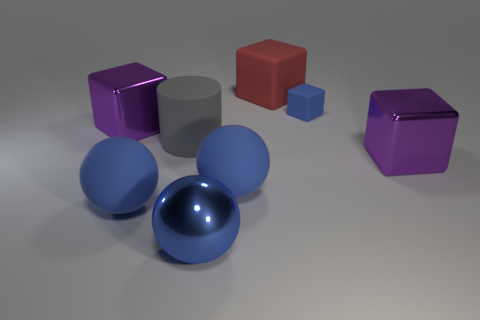What is the shape of the large blue object that is to the right of the metal object in front of the large purple cube that is on the right side of the red block?
Make the answer very short. Sphere. What number of things are either big blue balls on the right side of the big blue metal ball or metal blocks that are right of the blue cube?
Offer a very short reply. 2. Does the blue matte cube have the same size as the purple object that is on the left side of the big rubber cylinder?
Offer a very short reply. No. Do the big object to the right of the big rubber block and the large gray cylinder that is in front of the large red matte block have the same material?
Give a very brief answer. No. Are there the same number of tiny objects that are to the left of the small thing and purple metallic things that are behind the big gray rubber cylinder?
Provide a succinct answer. No. How many rubber cubes have the same color as the shiny ball?
Give a very brief answer. 1. What material is the tiny thing that is the same color as the metallic sphere?
Your answer should be very brief. Rubber. What number of matte things are either small blue cubes or large purple cubes?
Your answer should be compact. 1. Is the shape of the blue matte object to the right of the big red rubber thing the same as the purple metallic object that is to the left of the gray matte cylinder?
Your answer should be compact. Yes. How many big balls are behind the big gray thing?
Offer a very short reply. 0. 